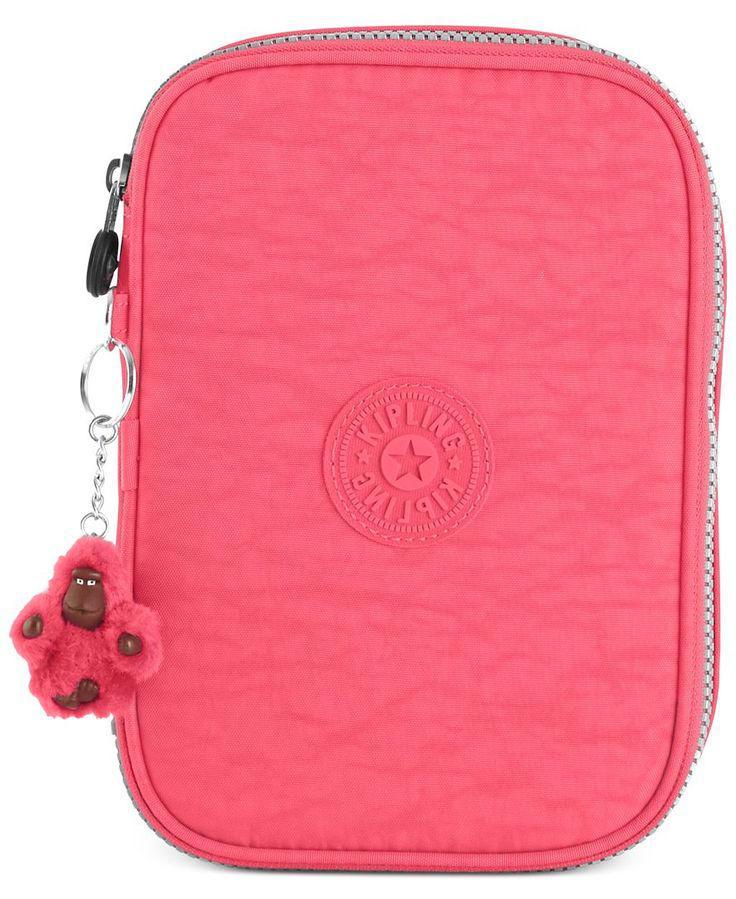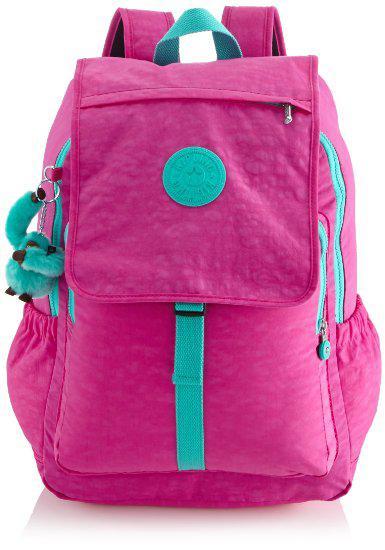The first image is the image on the left, the second image is the image on the right. Assess this claim about the two images: "Each image shows one zipper pencil case with rounded corners, and the cases in the left and right images are shown in the same position and configuration.". Correct or not? Answer yes or no. No. The first image is the image on the left, the second image is the image on the right. Given the left and right images, does the statement "One of the images shows a pink pencil case opened to reveal a blue lining on one side." hold true? Answer yes or no. No. 